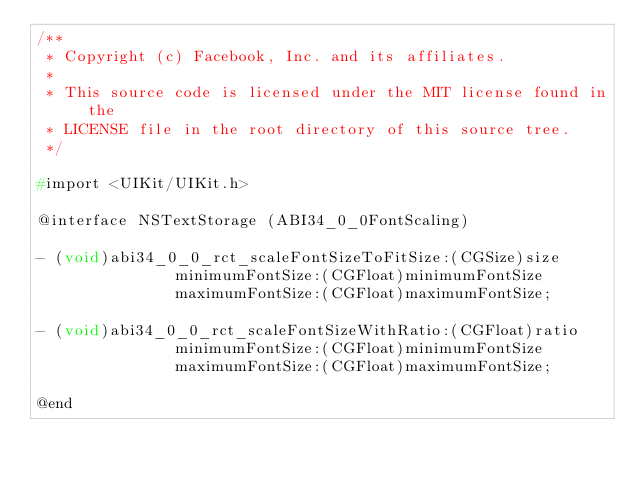Convert code to text. <code><loc_0><loc_0><loc_500><loc_500><_C_>/**
 * Copyright (c) Facebook, Inc. and its affiliates.
 *
 * This source code is licensed under the MIT license found in the
 * LICENSE file in the root directory of this source tree.
 */

#import <UIKit/UIKit.h>

@interface NSTextStorage (ABI34_0_0FontScaling)

- (void)abi34_0_0_rct_scaleFontSizeToFitSize:(CGSize)size
               minimumFontSize:(CGFloat)minimumFontSize
               maximumFontSize:(CGFloat)maximumFontSize;

- (void)abi34_0_0_rct_scaleFontSizeWithRatio:(CGFloat)ratio
               minimumFontSize:(CGFloat)minimumFontSize
               maximumFontSize:(CGFloat)maximumFontSize;

@end
</code> 